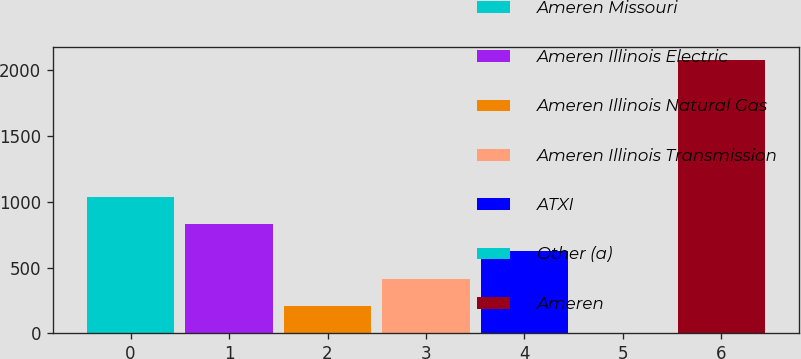<chart> <loc_0><loc_0><loc_500><loc_500><bar_chart><fcel>Ameren Missouri<fcel>Ameren Illinois Electric<fcel>Ameren Illinois Natural Gas<fcel>Ameren Illinois Transmission<fcel>ATXI<fcel>Other (a)<fcel>Ameren<nl><fcel>1039<fcel>831.6<fcel>209.4<fcel>416.8<fcel>624.2<fcel>2<fcel>2076<nl></chart> 